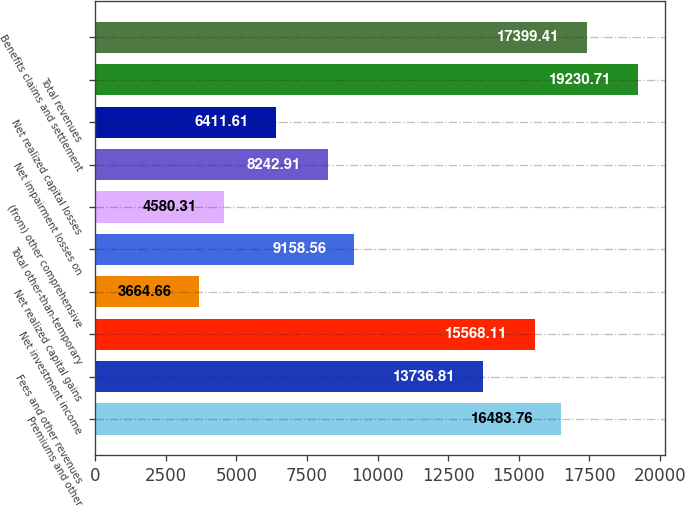Convert chart to OTSL. <chart><loc_0><loc_0><loc_500><loc_500><bar_chart><fcel>Premiums and other<fcel>Fees and other revenues<fcel>Net investment income<fcel>Net realized capital gains<fcel>Total other-than-temporary<fcel>(from) other comprehensive<fcel>Net impairment losses on<fcel>Net realized capital losses<fcel>Total revenues<fcel>Benefits claims and settlement<nl><fcel>16483.8<fcel>13736.8<fcel>15568.1<fcel>3664.66<fcel>9158.56<fcel>4580.31<fcel>8242.91<fcel>6411.61<fcel>19230.7<fcel>17399.4<nl></chart> 